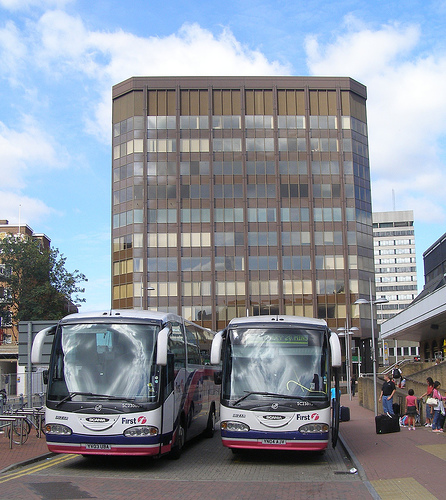Is the white bus to the right of a person? No, the white bus is positioned in the center and front of the image without any people to its right. 